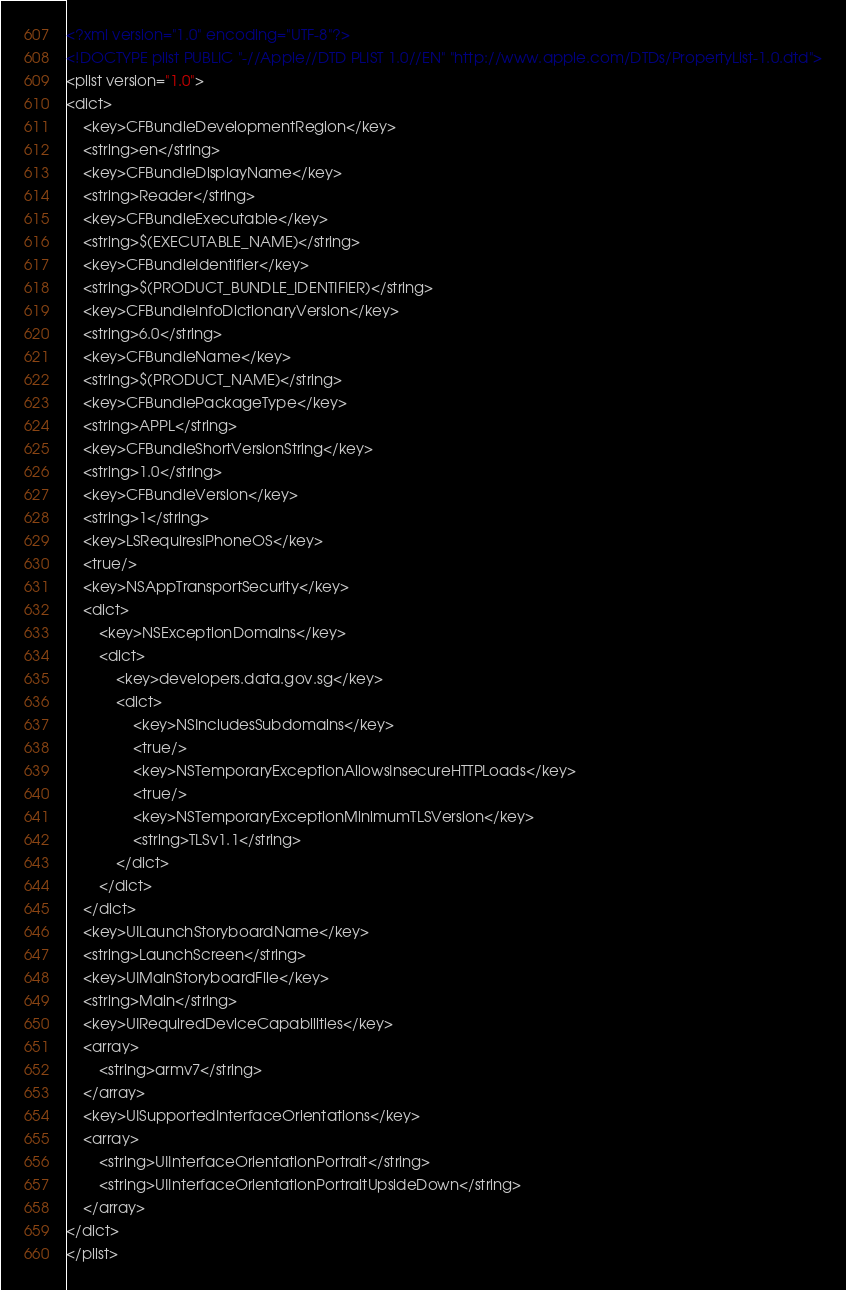Convert code to text. <code><loc_0><loc_0><loc_500><loc_500><_XML_><?xml version="1.0" encoding="UTF-8"?>
<!DOCTYPE plist PUBLIC "-//Apple//DTD PLIST 1.0//EN" "http://www.apple.com/DTDs/PropertyList-1.0.dtd">
<plist version="1.0">
<dict>
	<key>CFBundleDevelopmentRegion</key>
	<string>en</string>
	<key>CFBundleDisplayName</key>
	<string>Reader</string>
	<key>CFBundleExecutable</key>
	<string>$(EXECUTABLE_NAME)</string>
	<key>CFBundleIdentifier</key>
	<string>$(PRODUCT_BUNDLE_IDENTIFIER)</string>
	<key>CFBundleInfoDictionaryVersion</key>
	<string>6.0</string>
	<key>CFBundleName</key>
	<string>$(PRODUCT_NAME)</string>
	<key>CFBundlePackageType</key>
	<string>APPL</string>
	<key>CFBundleShortVersionString</key>
	<string>1.0</string>
	<key>CFBundleVersion</key>
	<string>1</string>
	<key>LSRequiresIPhoneOS</key>
	<true/>
	<key>NSAppTransportSecurity</key>
	<dict>
		<key>NSExceptionDomains</key>
		<dict>
			<key>developers.data.gov.sg</key>
			<dict>
				<key>NSIncludesSubdomains</key>
				<true/>
				<key>NSTemporaryExceptionAllowsInsecureHTTPLoads</key>
				<true/>
				<key>NSTemporaryExceptionMinimumTLSVersion</key>
				<string>TLSv1.1</string>
			</dict>
		</dict>
	</dict>
	<key>UILaunchStoryboardName</key>
	<string>LaunchScreen</string>
	<key>UIMainStoryboardFile</key>
	<string>Main</string>
	<key>UIRequiredDeviceCapabilities</key>
	<array>
		<string>armv7</string>
	</array>
	<key>UISupportedInterfaceOrientations</key>
	<array>
		<string>UIInterfaceOrientationPortrait</string>
		<string>UIInterfaceOrientationPortraitUpsideDown</string>
	</array>
</dict>
</plist>
</code> 